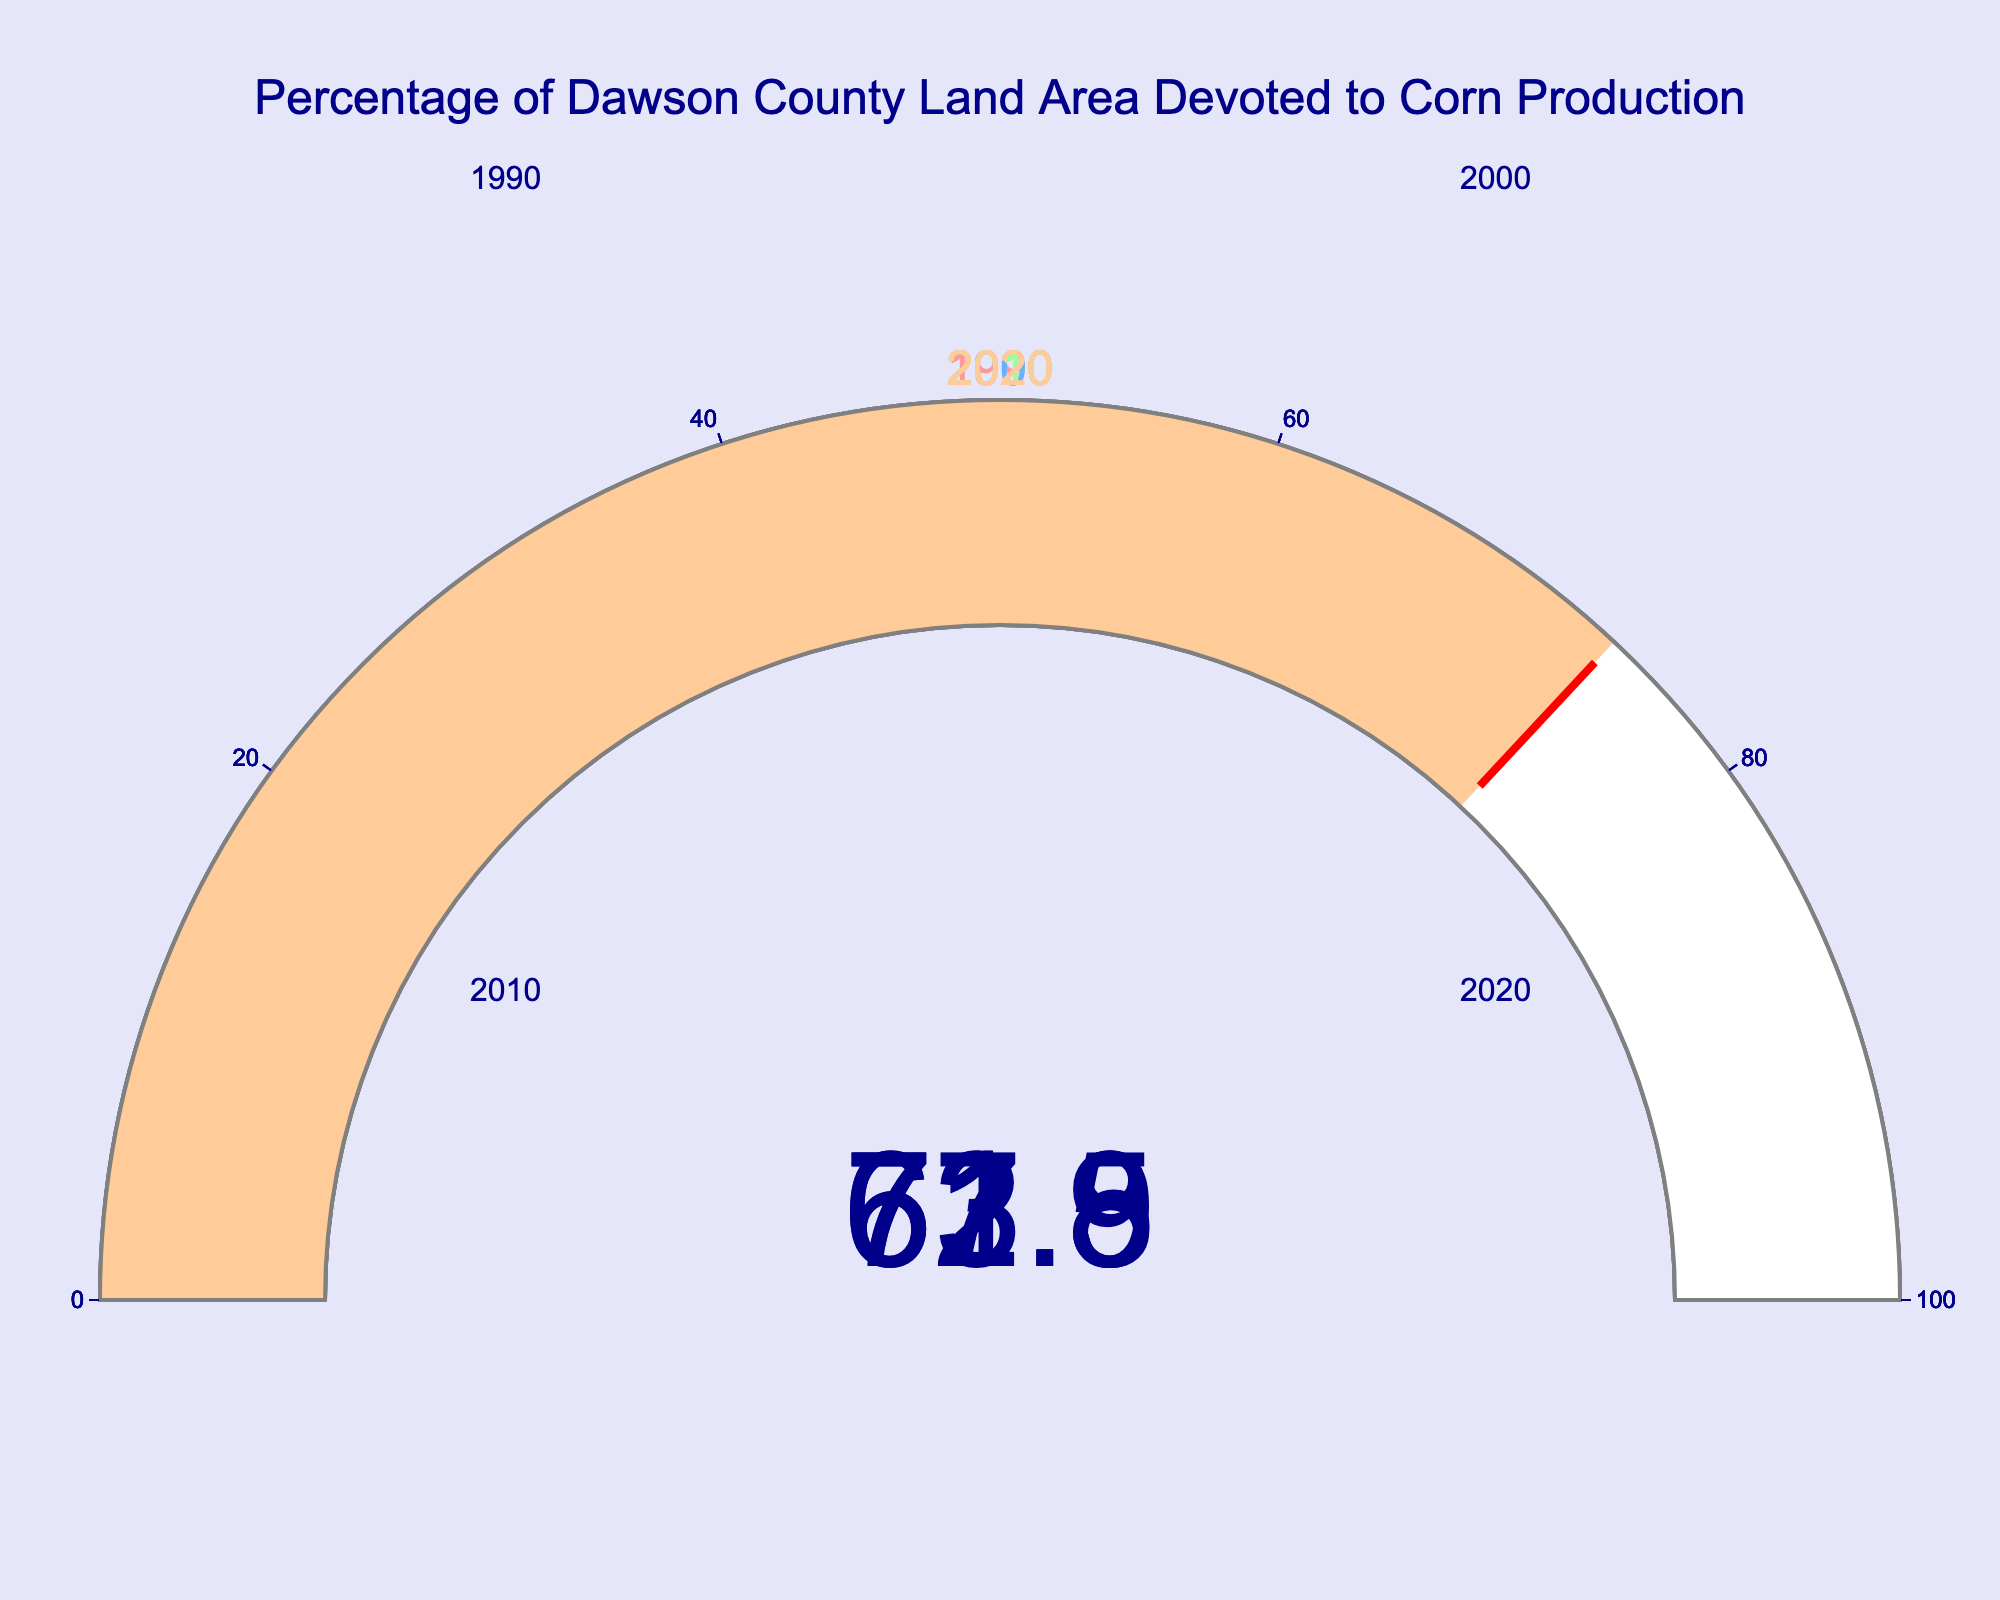What is the percentage of Dawson County land area devoted to corn production in 2010? We look at the gauge corresponding to the year 2010, which shows the percentage.
Answer: 71.3% How much did the percentage of land devoted to corn production increase from 1990 to 2020? Subtract the 1990 percentage from the 2020 percentage: 73.9% - 62.5% = 11.4%
Answer: 11.4% Which year had the highest percentage of Dawson County land area devoted to corn production? Compare the percentages for each year. The highest percentage is displayed in the gauge for 2020 with 73.9%.
Answer: 2020 Calculate the average percentage of land devoted to corn production over these four years. Sum the percentages and divide by the number of years: (62.5% + 67.8% + 71.3% + 73.9%) / 4 = 68.875%
Answer: 68.875% What is the range of the percentages of Dawson County land area devoted to corn production? Subtract the lowest percentage (62.5% in 1990) from the highest percentage (73.9% in 2020): 73.9% - 62.5% = 11.4%
Answer: 11.4% Did the percentage of land devoted to corn production increase or decrease from 2000 to 2010? Compare the percentage in 2000 (67.8%) with the percentage in 2010 (71.3%). The percentage increased.
Answer: Increase Which year had the smallest percentage increase in land area devoted to corn production compared to its previous recorded year? Calculate differences: 1990 to 2000: 67.8% - 62.5% = 5.3%, 2000 to 2010: 71.3% - 67.8% = 3.5%, 2010 to 2020: 73.9% - 71.3% = 2.6%. The smallest increase is from 2010 to 2020 (2.6%).
Answer: 2010 to 2020 By how much did the percentage of land devoted to corn production change from the year 2000 to the year 2020? Subtract the 2000 percentage from the 2020 percentage: 73.9% - 67.8% = 6.1%
Answer: 6.1% What percentage of the Dawson County land area is left for other uses in 2020? Subtract the percentage devoted to corn production in 2020 from 100%: 100% - 73.9% = 26.1%
Answer: 26.1% 